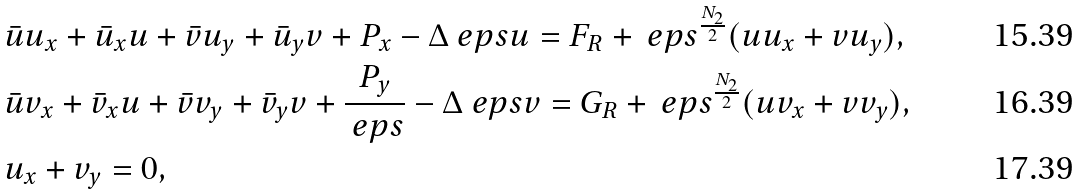Convert formula to latex. <formula><loc_0><loc_0><loc_500><loc_500>& \bar { u } u _ { x } + \bar { u } _ { x } u + \bar { v } u _ { y } + \bar { u } _ { y } v + P _ { x } - \Delta _ { \ } e p s u = F _ { R } + \ e p s ^ { \frac { N _ { 2 } } { 2 } } ( u u _ { x } + v u _ { y } ) , \\ & \bar { u } v _ { x } + \bar { v } _ { x } u + \bar { v } v _ { y } + \bar { v } _ { y } v + \frac { P _ { y } } { \ e p s } - \Delta _ { \ } e p s v = G _ { R } + \ e p s ^ { \frac { N _ { 2 } } { 2 } } ( u v _ { x } + v v _ { y } ) , \\ & u _ { x } + v _ { y } = 0 ,</formula> 